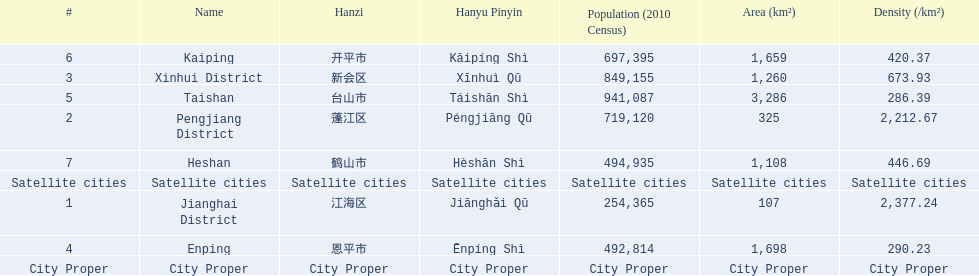What are all the cities? Jianghai District, Pengjiang District, Xinhui District, Enping, Taishan, Kaiping, Heshan. Of these, which are satellite cities? Enping, Taishan, Kaiping, Heshan. For these, what are their populations? 492,814, 941,087, 697,395, 494,935. Of these, which is the largest? 941,087. Which city has this population? Taishan. 